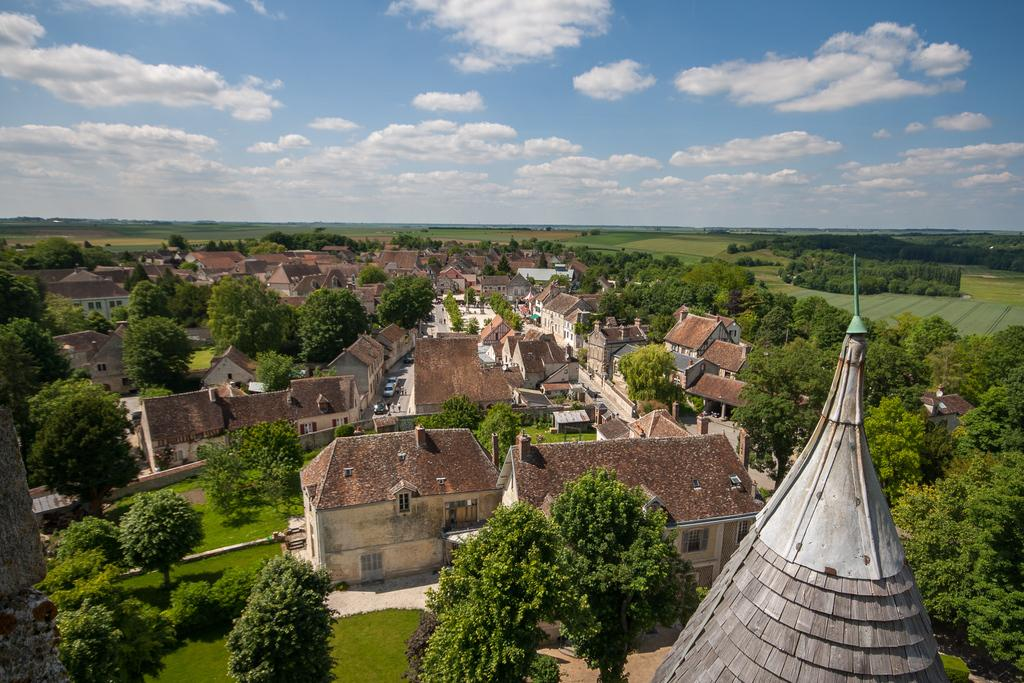What type of structures can be seen in the image? There are buildings in the image. What type of vegetation is present in the image? There are trees in the image. What can be seen in the sky in the image? There are clouds in the image. What type of ground cover is visible in the image? There is grass visible in the image. Can you tell me how many grapes are hanging from the trees in the image? There are no grapes present in the image; the trees are not fruit-bearing trees. Are there any boys visible in the image? There is no mention of boys or any people in the image; it only features buildings, trees, clouds, and grass. 